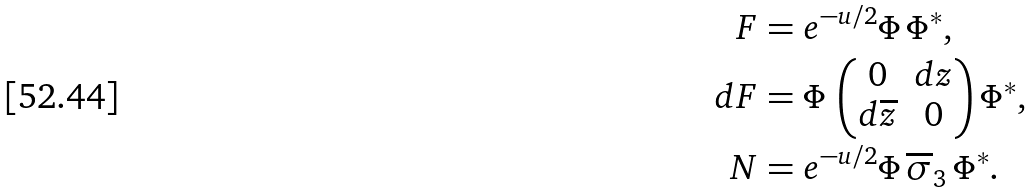<formula> <loc_0><loc_0><loc_500><loc_500>F & = e ^ { - u / 2 } \Phi \, \Phi ^ { * } , \\ d F & = \Phi \, \begin{pmatrix} 0 & d z \\ d \overline { z } & 0 \end{pmatrix} \Phi ^ { * } , \\ N & = e ^ { - u / 2 } \Phi \, \overline { \sigma } _ { 3 } \, \Phi ^ { * } .</formula> 